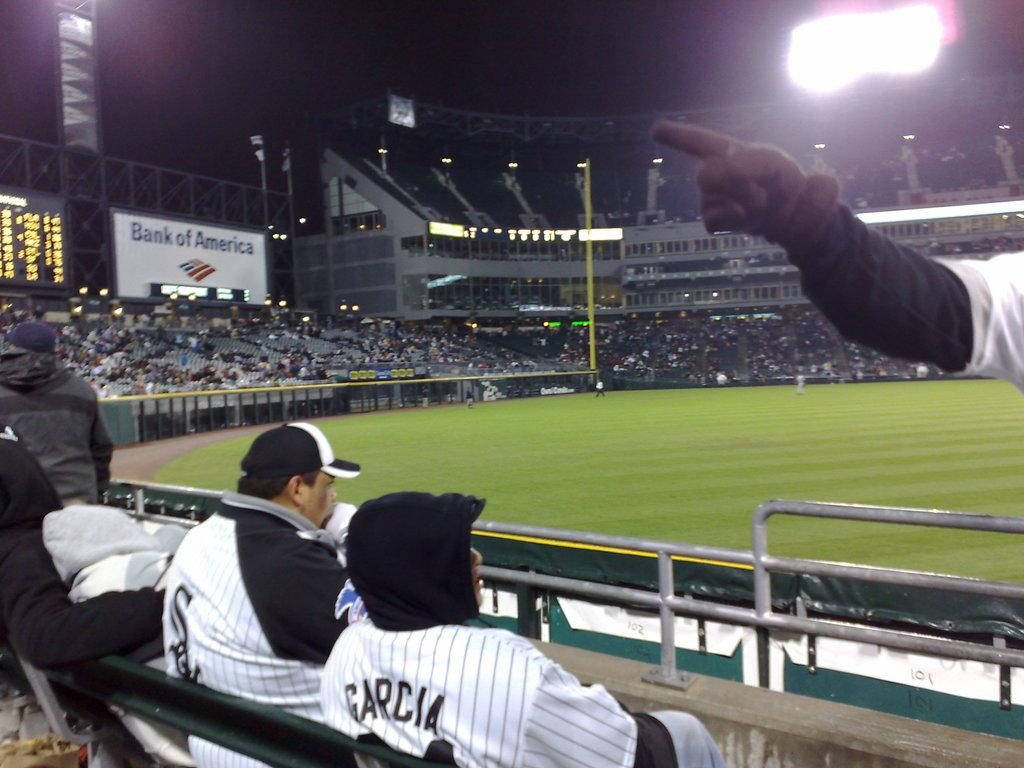<image>
Give a short and clear explanation of the subsequent image. A couple of men, one wearing a Garcia jersey sitting in the cold at a baseball game. 